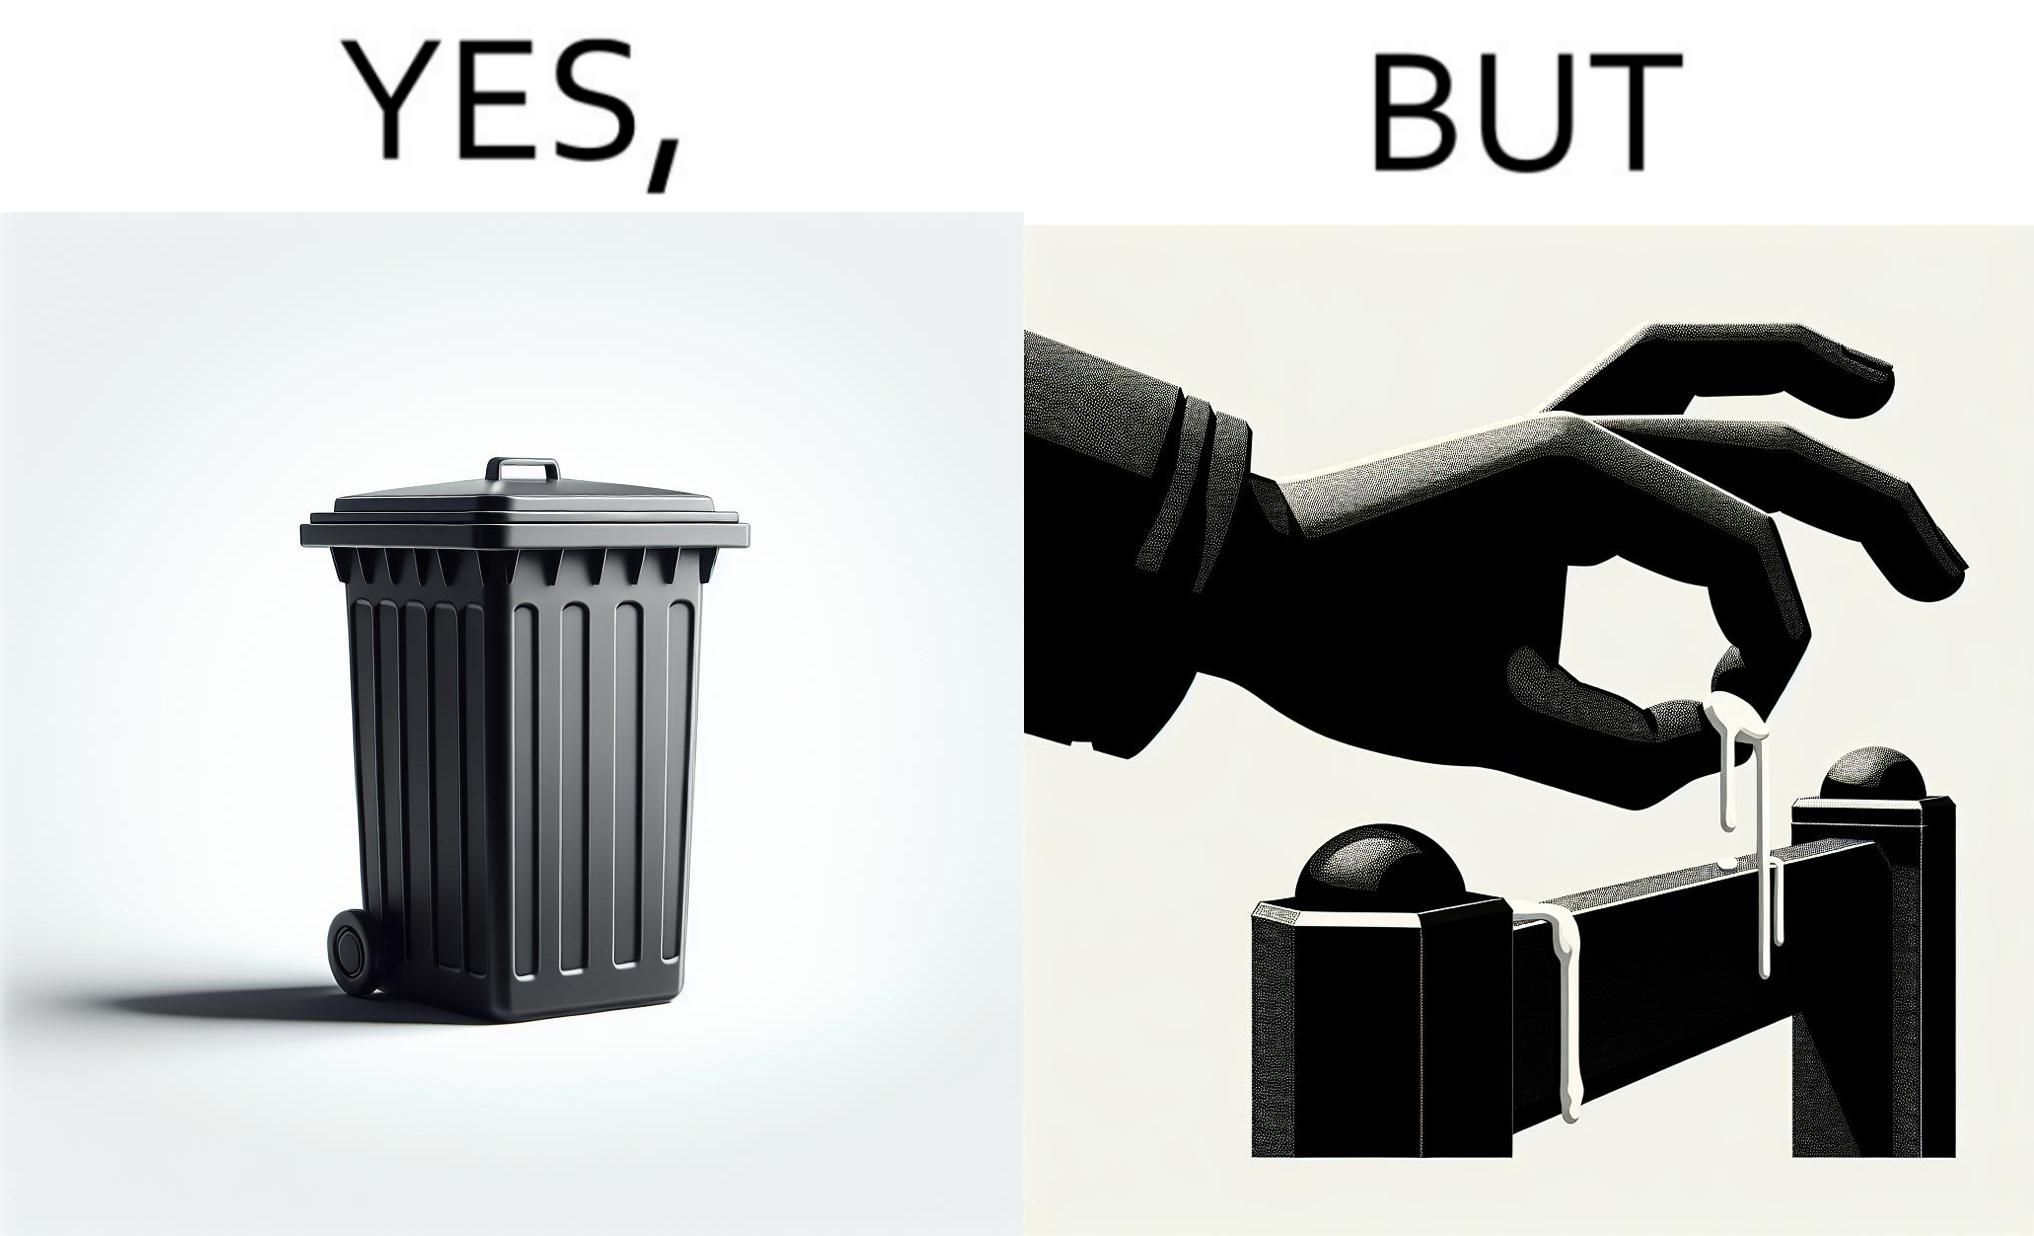Explain why this image is satirical. The images are ironic because even though garbage bins are provided for humans to dispose waste, by habit humans still choose to make surroundings dirty by disposing garbage improperly 